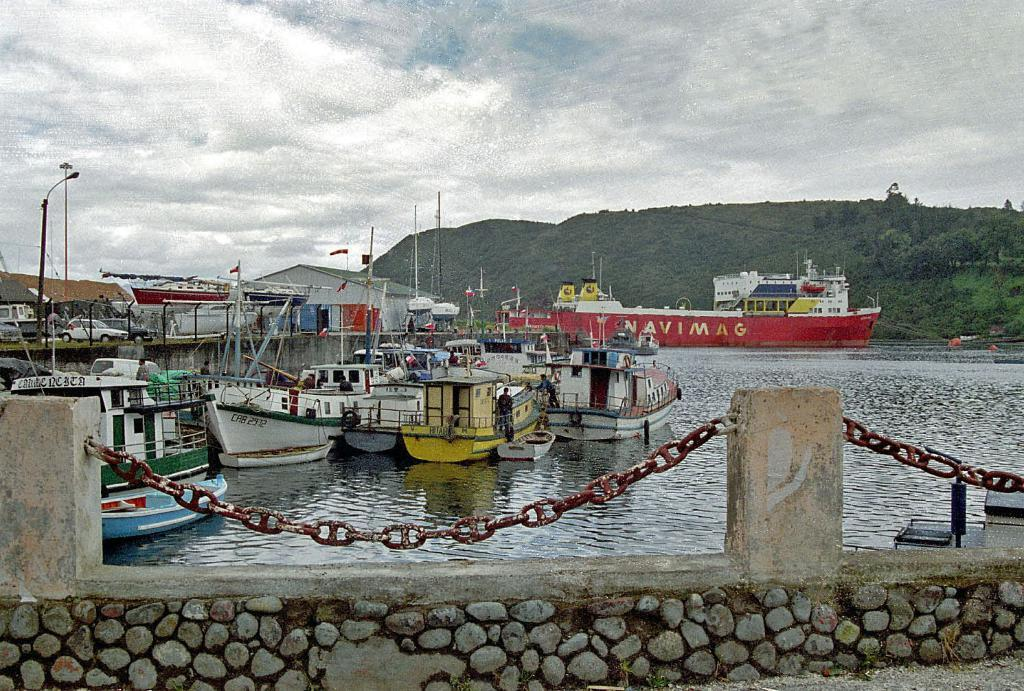What type of vehicles are in the image? There are boats in the image. What are the people on the boats doing? The people are standing on the boats. What is the main body of water in the image? There is water in the image. What type of landscape can be seen in the background? There are mountains in the image. What is visible at the top of the image? The sky is visible at the top of the image. Can you see any lips on the boats in the image? There are no lips present in the image; it features boats on water with people standing on them. Are there any worms crawling on the mountains in the image? There are no worms visible in the image; it only shows boats, people, water, mountains, and the sky. 